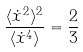Convert formula to latex. <formula><loc_0><loc_0><loc_500><loc_500>\frac { \langle \dot { x } ^ { 2 } \rangle ^ { 2 } } { \langle \dot { x } ^ { 4 } \rangle } = \frac { 2 } { 3 }</formula> 